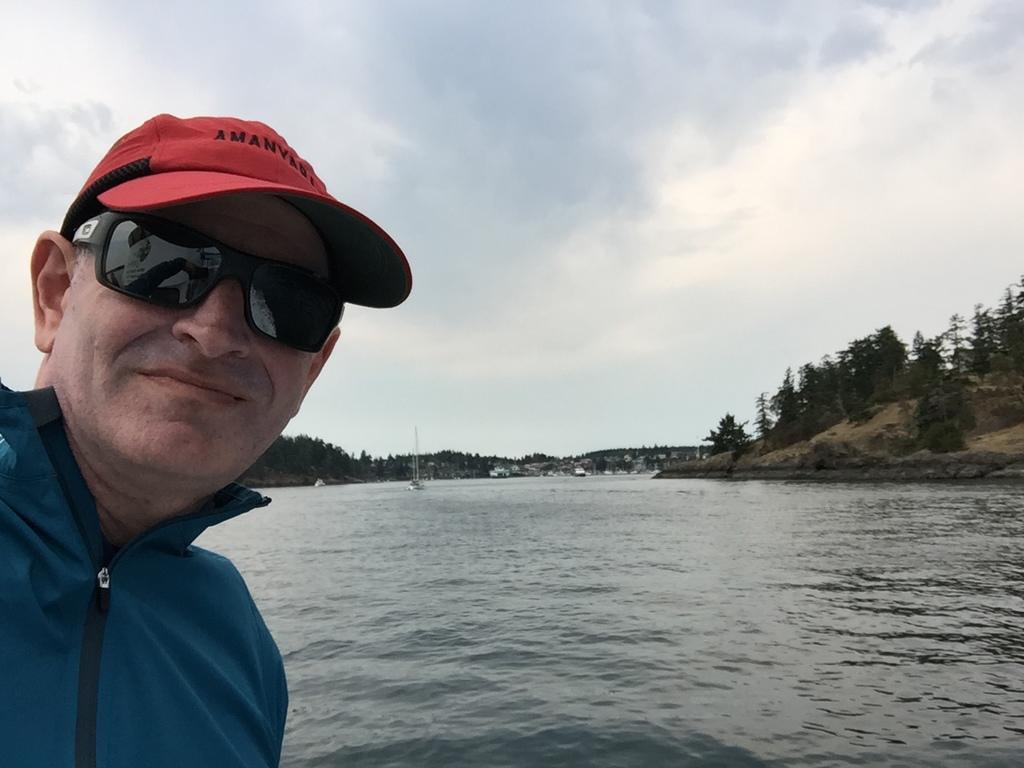Please provide a concise description of this image. In this image we can see a man smiling. In the background there are lake, trees, hills, motor vehicle, ships on the water, and sky with clouds. 